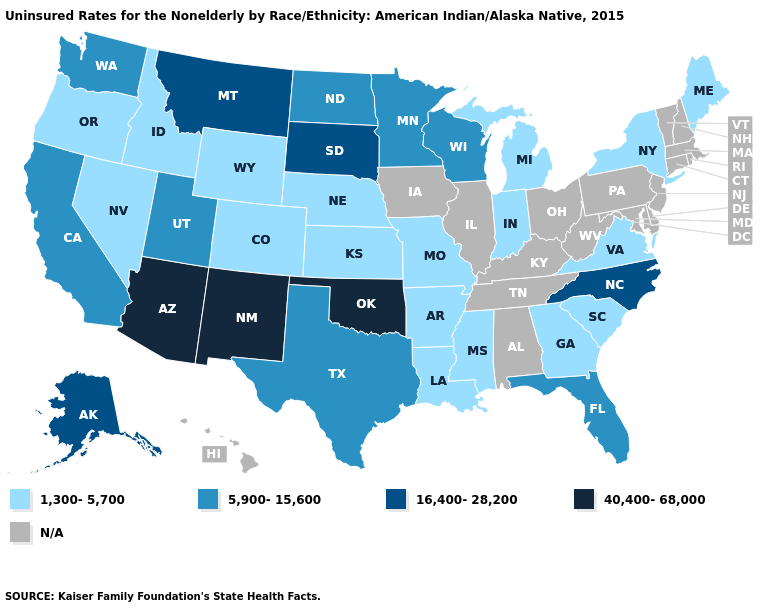What is the value of Kentucky?
Answer briefly. N/A. What is the lowest value in the USA?
Be succinct. 1,300-5,700. What is the lowest value in the USA?
Answer briefly. 1,300-5,700. Does the first symbol in the legend represent the smallest category?
Quick response, please. Yes. Name the states that have a value in the range 40,400-68,000?
Answer briefly. Arizona, New Mexico, Oklahoma. What is the value of Pennsylvania?
Be succinct. N/A. Does New Mexico have the highest value in the USA?
Concise answer only. Yes. What is the lowest value in the MidWest?
Concise answer only. 1,300-5,700. What is the value of California?
Short answer required. 5,900-15,600. Does the map have missing data?
Keep it brief. Yes. How many symbols are there in the legend?
Short answer required. 5. 